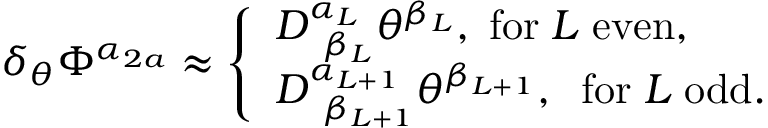<formula> <loc_0><loc_0><loc_500><loc_500>\delta _ { \theta } \Phi ^ { \alpha _ { 2 a } } \approx \left \{ \begin{array} { l } { { D _ { \, \beta _ { L } } ^ { \alpha _ { L } } \theta ^ { \beta _ { L } } , \, f o r \, L \, e v e n , } } \\ { { D _ { \, \beta _ { L + 1 } } ^ { \alpha _ { L + 1 } } \theta ^ { \beta _ { L + 1 } } , \, f o r \, L \, o d d . } } \end{array}</formula> 